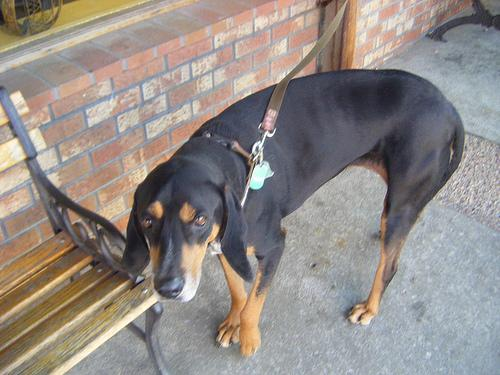What kind of material is the bench made of, and what type of wall is behind the dog? The bench is made of wood and metal, and there is a red brick wall behind the dog. What type of wall and bench are in the background of the image? There's a brick wall and a wooden bench with metal accents in the background. What is the color of the leash and collar on the dog? The leash and collar are brown. Mention the key elements depicted in the image along with the dog. A wooden bench, a brick wall, a brown collar, and a brown leash are some key elements present in the image along with the dog. Describe the dog's appearance and its surroundings in a comprehensive manner. The image features a black and brown dog with brown spots, brown eyes, a brown collar, and a brown leash. The dog appears to be sad and is exhibiting poor body language in a cowardly pose. Its surroundings include a brick wall, a wooden bench with metal accents, and a sidewalk where it stands. How does the dog feel in the image, and what is the primary reason for its emotions? The dog appears sad and is displaying poor body language due to its cowering posture. Provide a short description of the main subjects and their surroundings in the image. A sad, black and brown dog with a brown leash and collar is standing in a cowardly pose on the sidewalk, near a wooden bench and a brick wall. Briefly narrate the scene presented in the image, focusing on the dog's emotions and surroundings. The image portrays a sad-looking, black and brown dog exhibiting a cowardly pose while standing on a sidewalk. The dog has a brown collar and leash, and is placed near a wooden bench and brick wall. What are the main objects and subjects captured in the image, and what is their connection to one another? The primary objects are a sad, black and brown dog with a brown collar and leash, the bench, and the brick wall. The dog is standing on the sidewalk near the bench and the wall, seemingly in a public place. Identify the type of dog present in the image and describe its mood. The dog appears to be a sad Rottweiler-colored dog displaying poor body language and a cowering stance. Can you find a white cat in the image? There is no mention of a white cat in the list of objects in the image. The misleading instruction assumes an object that does not exist. What is the dominant material of the wall in the image? Red brick Examine the intricate details on the wooden sculpture in the window. The objects mention a metal sculpture, not a wooden sculpture. The instruction suggests a wrong attribute for an existing object (sculpture). The dog is wagging its long tail happily. There is an object mentioning a tucked black dog tail. This instruction implies a different attribute (long and wagging) for an existing object (tail). State any emotion or character trait you can deduce from the dog's appearance. The dog appears sad or timid. What is the dog doing in the image? The dog is standing in a cowardly pose. Describe the ground in the image. Gravel spread on the ground and a section of aggregate Can you see a child sitting on the bench next to the dog? There is no mention of a child in the list of objects. The misleading question assumes the presence of a person that does not exist in the image. Notice the large purple ribbon on the dog's collar. There is no mention of a purple ribbon in any of the objects. This instruction suggests a wrong attribute for an existing object (dog's collar). Rewrite this description with a formal style: "A sad looking dog with poor body language standing in front of a brick wall and next to a wooden bench." The canine exhibits a melancholic demeanor and displays an unfavorable posture while standing adjacent to a wooden bench and before a brick wall. Choose the correct description for the dog's body language: a) Happy and playful, b) Sad and cowardly, c) Angry and aggressive, d) Calm and relaxed b) Sad and cowardly What is the color of the dog's leash? Brown Is there a window in the image? If yes, describe it. Yes, it has a brick wall under the window and a windowsill made of brick. What is the color combination of the dog in the image? Black and brown List the objects you can see in the window. A metal sculpture and a decoration Describe the bench in the image. Wooden bench, decorated with black ironwork on the side. Is the dog sitting comfortably on the grass? There is no mention of grass or a sitting pose for the dog. This instruction implies a different posture of the dog and a different ground surface. Identify the materials of the bench in the image. Wood and metal What color are the tags on the dog's collar? Blue How many bicycles can you count in the image? There is no mention of bicycles in the list of objects. The misleading question assumes the presence of an object that does not exist in the image. Is the bench painted in bright colors? There is a mention of a metal and wood bench, but no details on its color are provided. The instruction suggests a wrong attribute (bright colors) for an existing object (bench). Can you spot the yellow fire hydrant beside the bench? There is no object mentioning a fire hydrant in the image. The misleading question assumes the presence of an object that does not exist in the image. Create a humorous image caption for the dog in the photo. "First day on the job as park security, already not loving it." Take note of the green leaves on the tree behind the wall. There are no objects related to a tree or green leaves in the image. This instruction assumes an object that does not exist. Is there any text visible in the image? If so, describe it. No visible text Is the dog's tail visible in the image? If so, describe its position. Yes, it's tucked and black. What is attached to the dog's collar? A leash and blue tags 